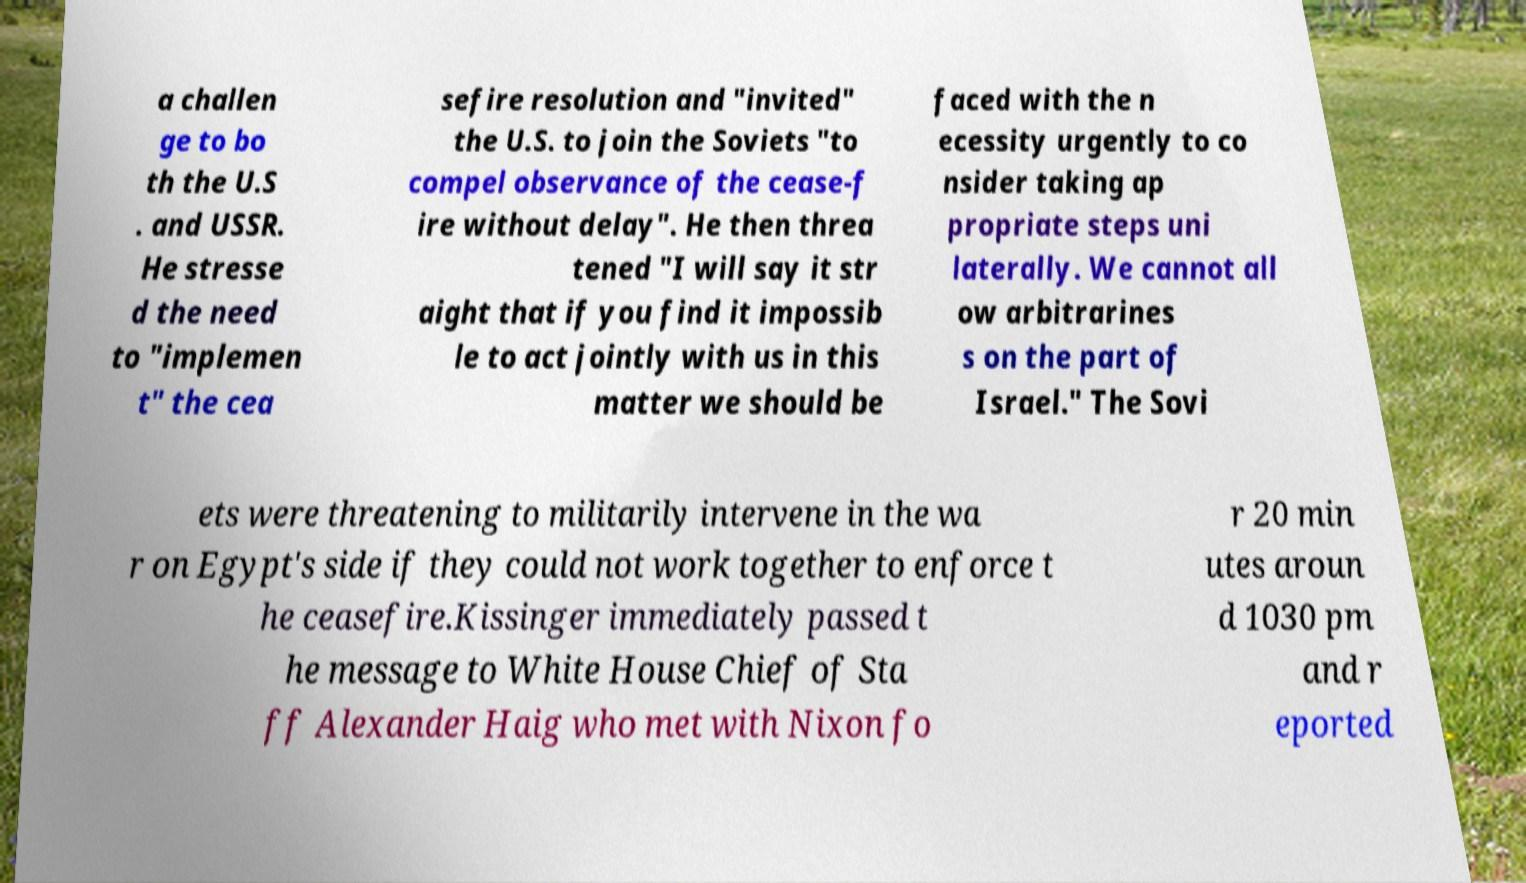Could you assist in decoding the text presented in this image and type it out clearly? a challen ge to bo th the U.S . and USSR. He stresse d the need to "implemen t" the cea sefire resolution and "invited" the U.S. to join the Soviets "to compel observance of the cease-f ire without delay". He then threa tened "I will say it str aight that if you find it impossib le to act jointly with us in this matter we should be faced with the n ecessity urgently to co nsider taking ap propriate steps uni laterally. We cannot all ow arbitrarines s on the part of Israel." The Sovi ets were threatening to militarily intervene in the wa r on Egypt's side if they could not work together to enforce t he ceasefire.Kissinger immediately passed t he message to White House Chief of Sta ff Alexander Haig who met with Nixon fo r 20 min utes aroun d 1030 pm and r eported 